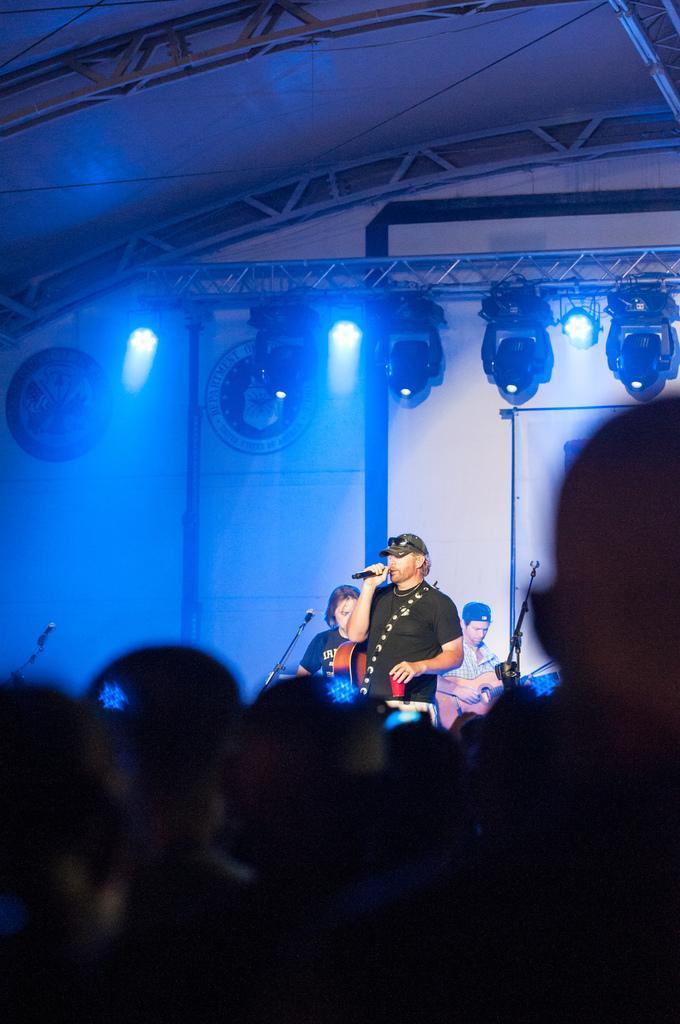Please provide a concise description of this image. It is a music concert, there are total three people on the dais, one person is standing and singing and the remaining two are sitting and playing the music instruments, in front of them there is a huge crowd and in the background there are blue color lights focusing on the stage. 